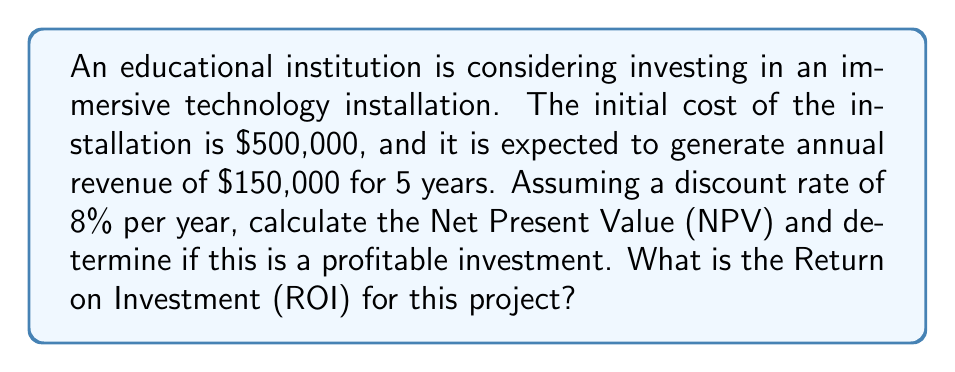Can you solve this math problem? To solve this problem, we'll use the Net Present Value (NPV) formula and calculate the Return on Investment (ROI).

Step 1: Calculate the NPV
The NPV formula is:

$$NPV = -C_0 + \sum_{t=1}^{n} \frac{C_t}{(1+r)^t}$$

Where:
$C_0$ = Initial investment
$C_t$ = Cash flow at time t
$r$ = Discount rate
$n$ = Number of periods

Let's calculate the present value of each year's cash flow:

Year 1: $\frac{150,000}{(1+0.08)^1} = 138,888.89$
Year 2: $\frac{150,000}{(1+0.08)^2} = 128,600.82$
Year 3: $\frac{150,000}{(1+0.08)^3} = 119,074.84$
Year 4: $\frac{150,000}{(1+0.08)^4} = 110,254.48$
Year 5: $\frac{150,000}{(1+0.08)^5} = 102,087.48$

Sum of present values: $598,906.51$

NPV = $-500,000 + 598,906.51 = 98,906.51$

Since the NPV is positive, this is a profitable investment.

Step 2: Calculate the ROI
The ROI formula is:

$$ROI = \frac{\text{Net Profit}}{\text{Cost of Investment}} \times 100\%$$

Net Profit = Total Revenue - Cost of Investment
Total Revenue (undiscounted) = $150,000 \times 5 = 750,000$
Net Profit = $750,000 - 500,000 = 250,000$

$$ROI = \frac{250,000}{500,000} \times 100\% = 50\%$$
Answer: NPV = $98,906.51, ROI = 50% 